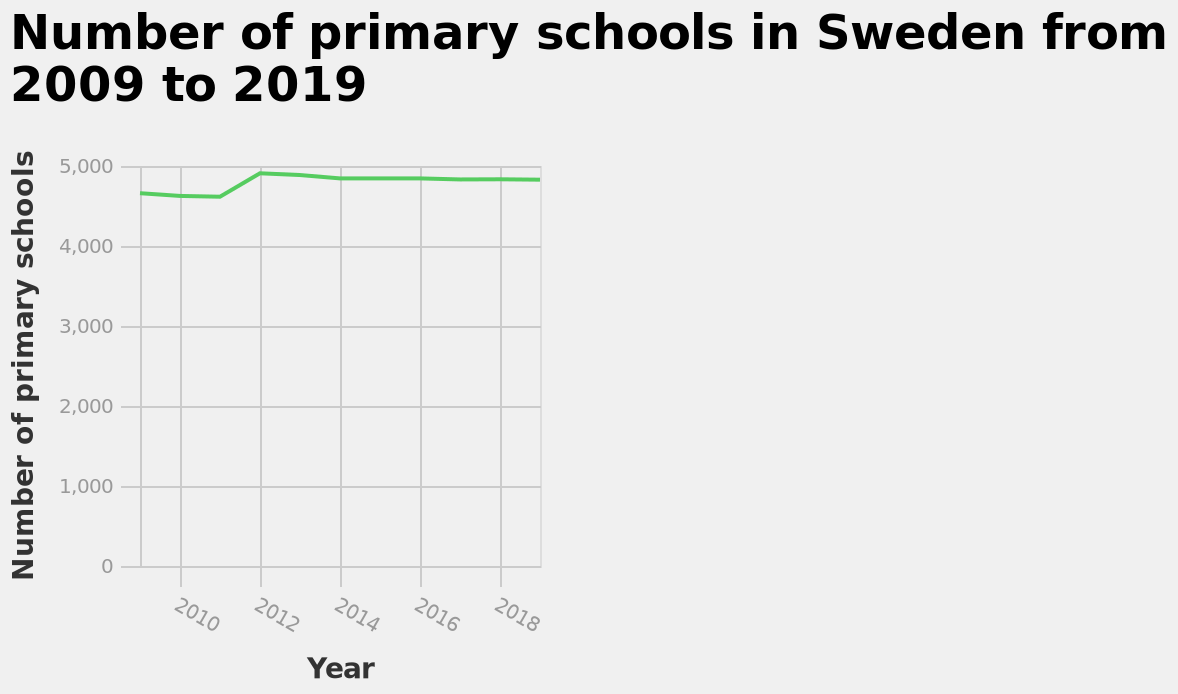<image>
Is the number of schools consistent over time?  No, there is variability in the number of schools over time. How would you describe the trend in the number of schools after 2011?  The trend in the number of schools after 2011 is stable or consistent. 